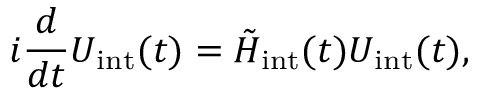Convert formula to latex. <formula><loc_0><loc_0><loc_500><loc_500>i \frac { d } { d t } U _ { i n t } ( t ) = \tilde { H } _ { i n t } ( t ) U _ { i n t } ( t ) ,</formula> 